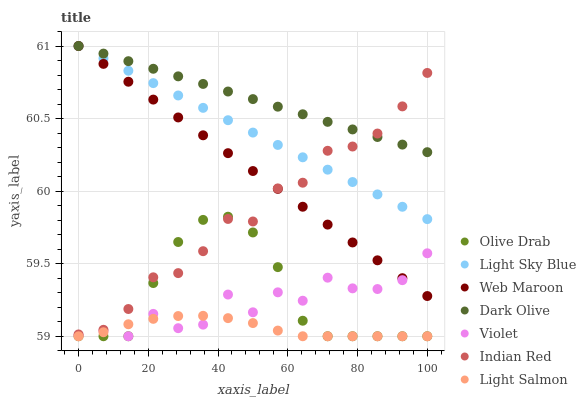Does Light Salmon have the minimum area under the curve?
Answer yes or no. Yes. Does Dark Olive have the maximum area under the curve?
Answer yes or no. Yes. Does Web Maroon have the minimum area under the curve?
Answer yes or no. No. Does Web Maroon have the maximum area under the curve?
Answer yes or no. No. Is Dark Olive the smoothest?
Answer yes or no. Yes. Is Violet the roughest?
Answer yes or no. Yes. Is Web Maroon the smoothest?
Answer yes or no. No. Is Web Maroon the roughest?
Answer yes or no. No. Does Light Salmon have the lowest value?
Answer yes or no. Yes. Does Web Maroon have the lowest value?
Answer yes or no. No. Does Light Sky Blue have the highest value?
Answer yes or no. Yes. Does Indian Red have the highest value?
Answer yes or no. No. Is Light Salmon less than Web Maroon?
Answer yes or no. Yes. Is Light Sky Blue greater than Olive Drab?
Answer yes or no. Yes. Does Violet intersect Light Salmon?
Answer yes or no. Yes. Is Violet less than Light Salmon?
Answer yes or no. No. Is Violet greater than Light Salmon?
Answer yes or no. No. Does Light Salmon intersect Web Maroon?
Answer yes or no. No. 